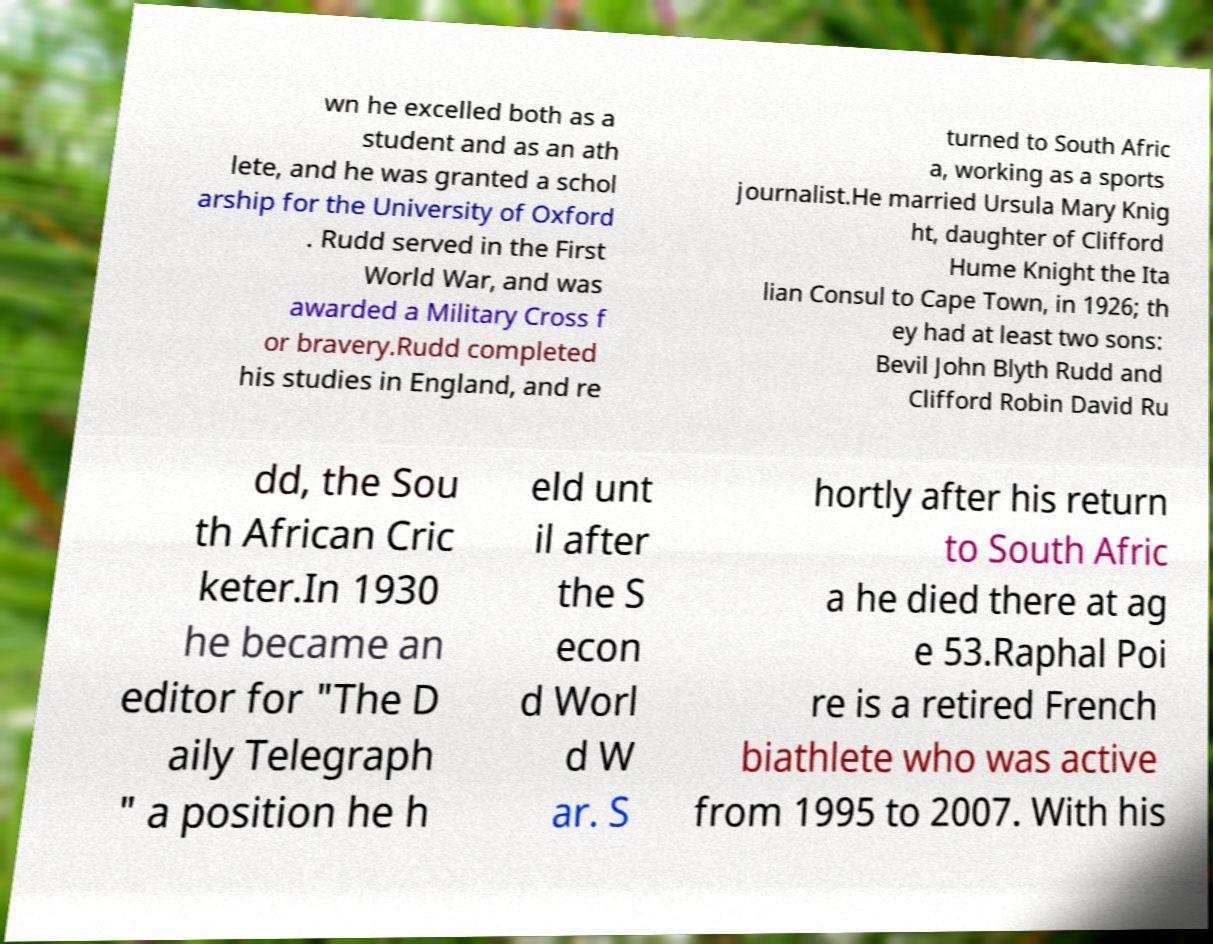Can you accurately transcribe the text from the provided image for me? wn he excelled both as a student and as an ath lete, and he was granted a schol arship for the University of Oxford . Rudd served in the First World War, and was awarded a Military Cross f or bravery.Rudd completed his studies in England, and re turned to South Afric a, working as a sports journalist.He married Ursula Mary Knig ht, daughter of Clifford Hume Knight the Ita lian Consul to Cape Town, in 1926; th ey had at least two sons: Bevil John Blyth Rudd and Clifford Robin David Ru dd, the Sou th African Cric keter.In 1930 he became an editor for "The D aily Telegraph " a position he h eld unt il after the S econ d Worl d W ar. S hortly after his return to South Afric a he died there at ag e 53.Raphal Poi re is a retired French biathlete who was active from 1995 to 2007. With his 